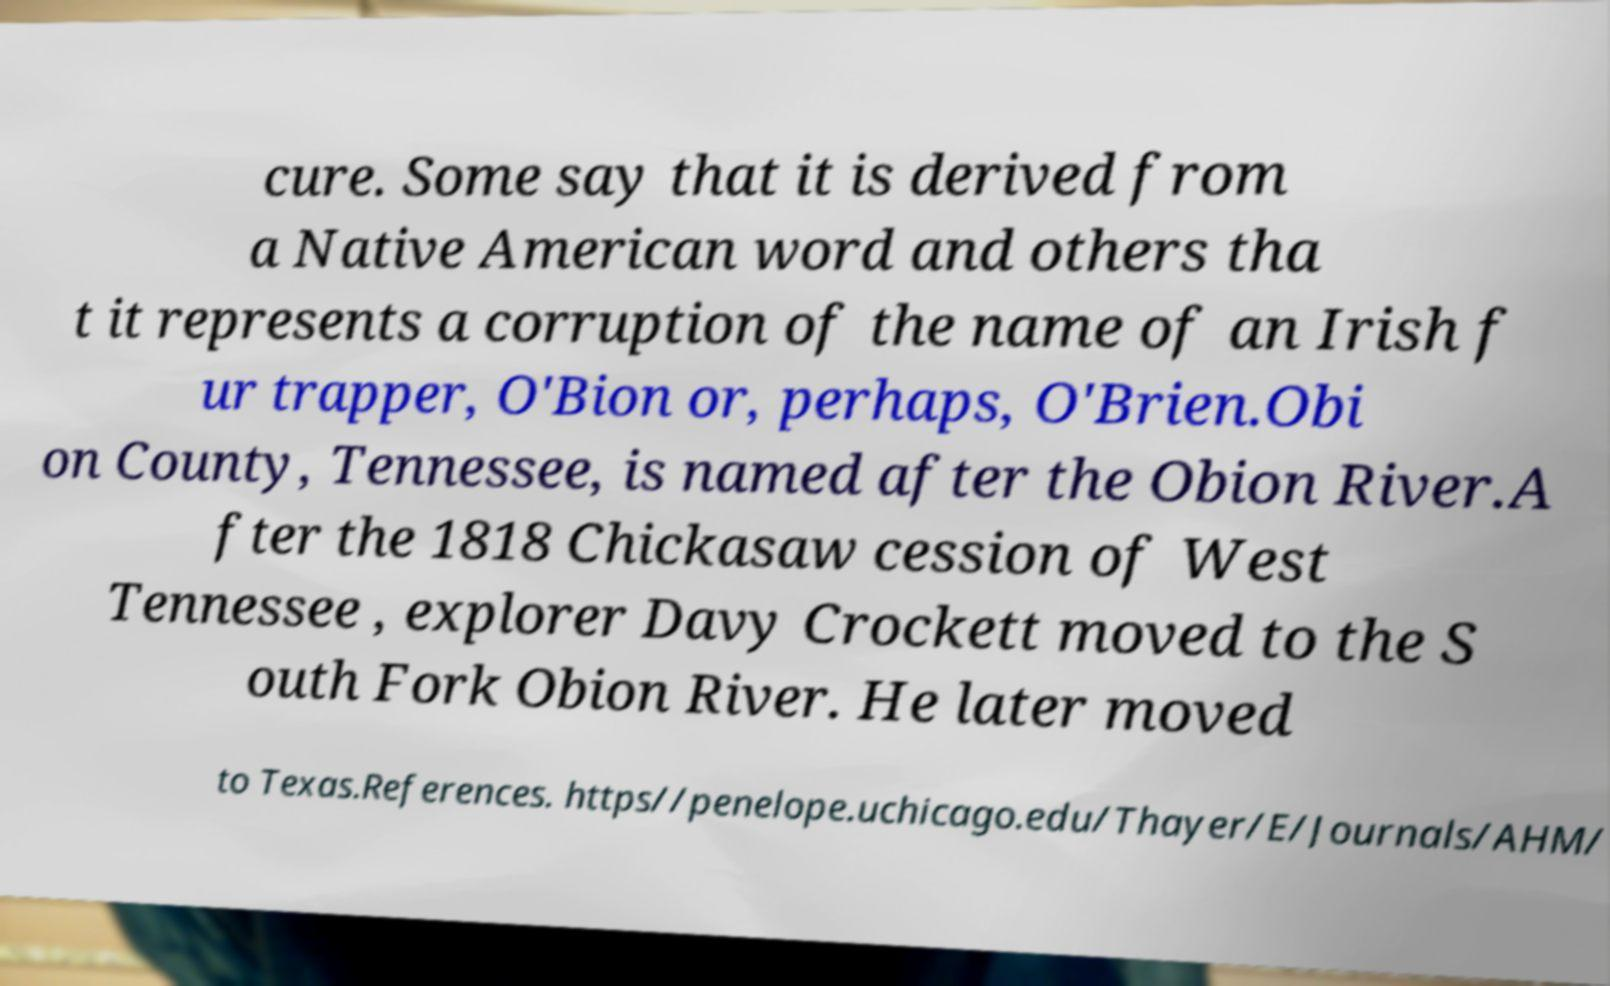Could you extract and type out the text from this image? cure. Some say that it is derived from a Native American word and others tha t it represents a corruption of the name of an Irish f ur trapper, O'Bion or, perhaps, O'Brien.Obi on County, Tennessee, is named after the Obion River.A fter the 1818 Chickasaw cession of West Tennessee , explorer Davy Crockett moved to the S outh Fork Obion River. He later moved to Texas.References. https//penelope.uchicago.edu/Thayer/E/Journals/AHM/ 